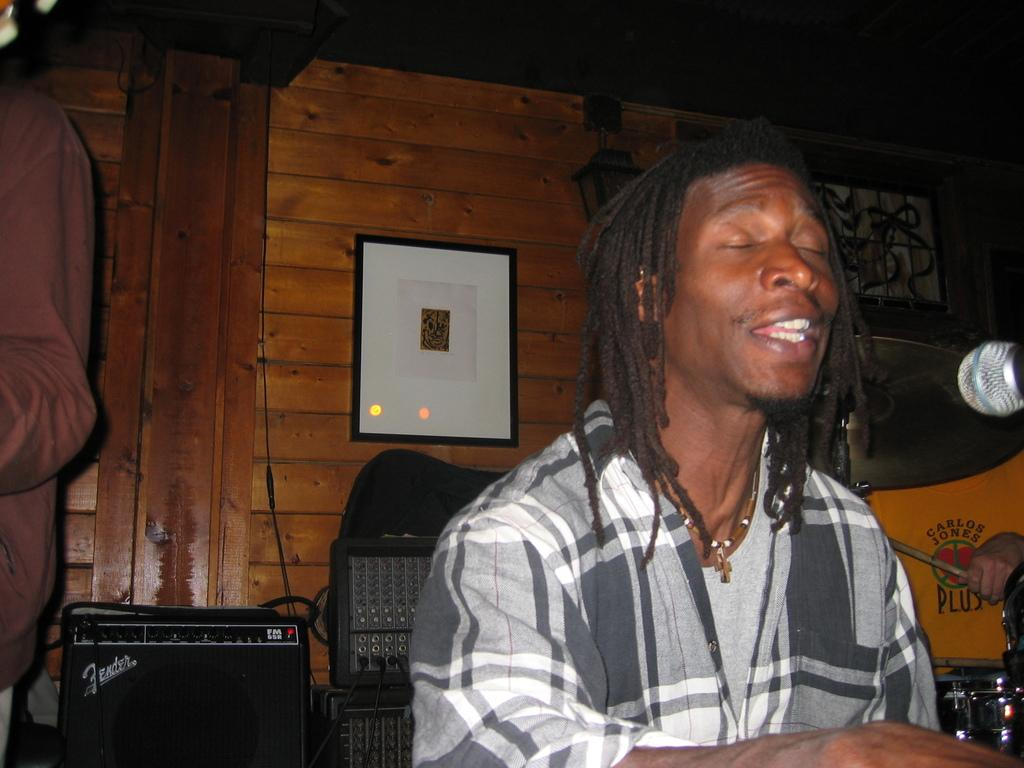Who is present in the image? There is a man in the image. What is the setting of the image? The man is sitting in a wooden room. What is the man doing in the image? The man is singing. What object is in front of the man? There is a microphone in front of the man. What type of sofa is visible in the image? There is no sofa present in the image. Can you describe the sea in the image? There is no sea present in the image. 